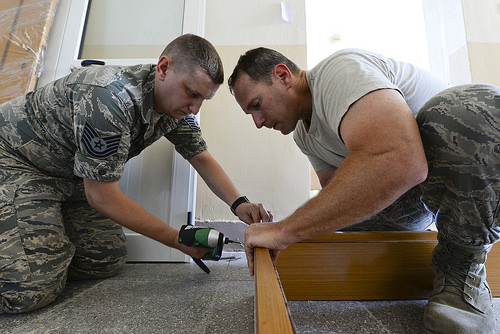<image>
Can you confirm if the man is on the wood? No. The man is not positioned on the wood. They may be near each other, but the man is not supported by or resting on top of the wood. Is the drill to the right of the wood? No. The drill is not to the right of the wood. The horizontal positioning shows a different relationship. 